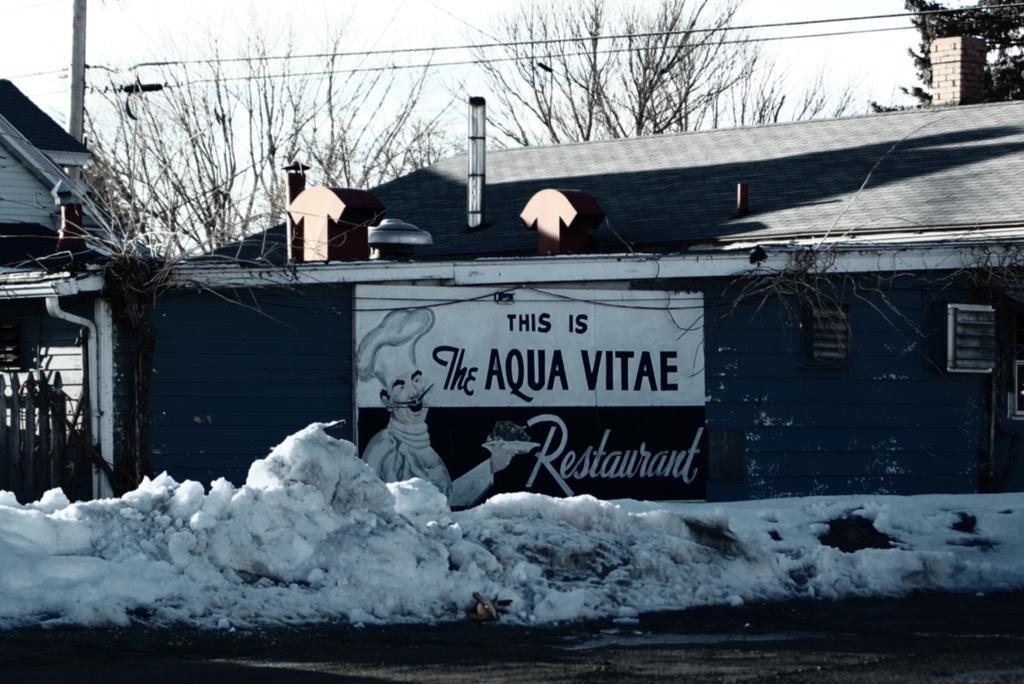Please provide a concise description of this image. In this image we can see a shed. There are many trees in the image. There is an electrical pole and many cables connected to it. There is a road and snow in the image. There is a sky in the image. There is an advertising board in the image. 